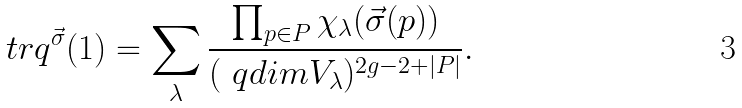<formula> <loc_0><loc_0><loc_500><loc_500>\ t r q ^ { \vec { \sigma } } ( 1 ) = \sum _ { \lambda } \frac { \prod _ { p \in P } \chi _ { \lambda } ( \vec { \sigma } ( p ) ) } { ( \ q d i m V _ { \lambda } ) ^ { 2 g - 2 + | P | } } .</formula> 